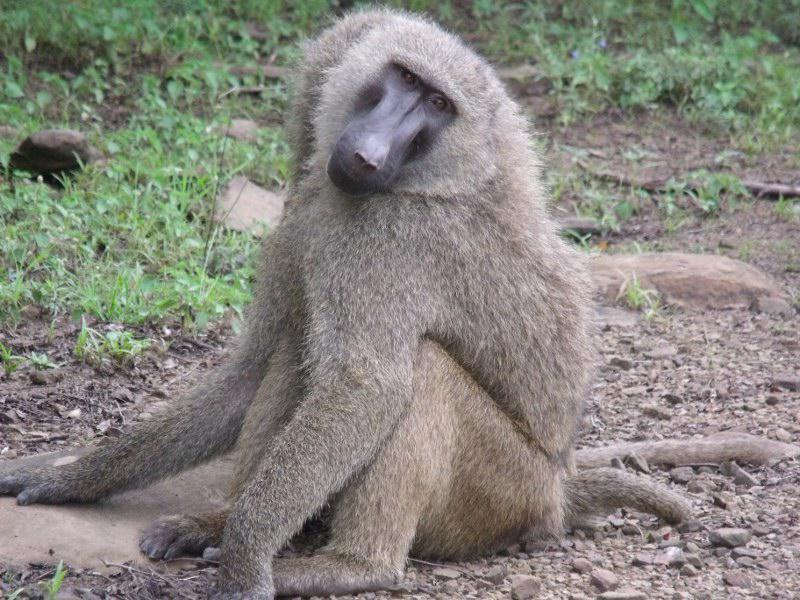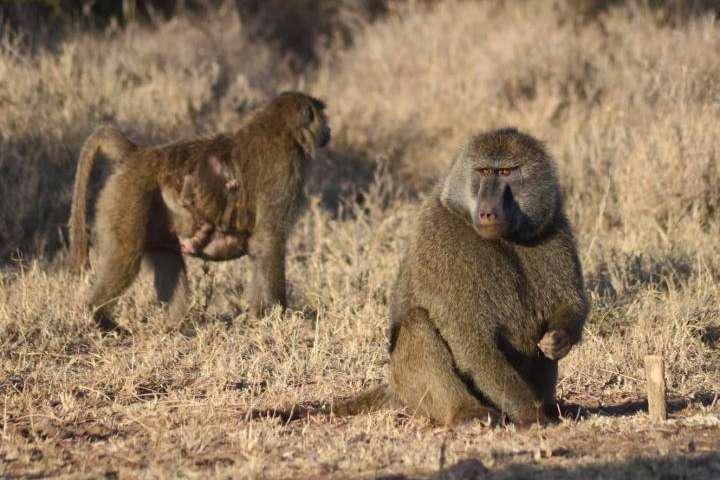The first image is the image on the left, the second image is the image on the right. Examine the images to the left and right. Is the description "One baboon sits with bent knees and its body turned leftward, in an image." accurate? Answer yes or no. Yes. 